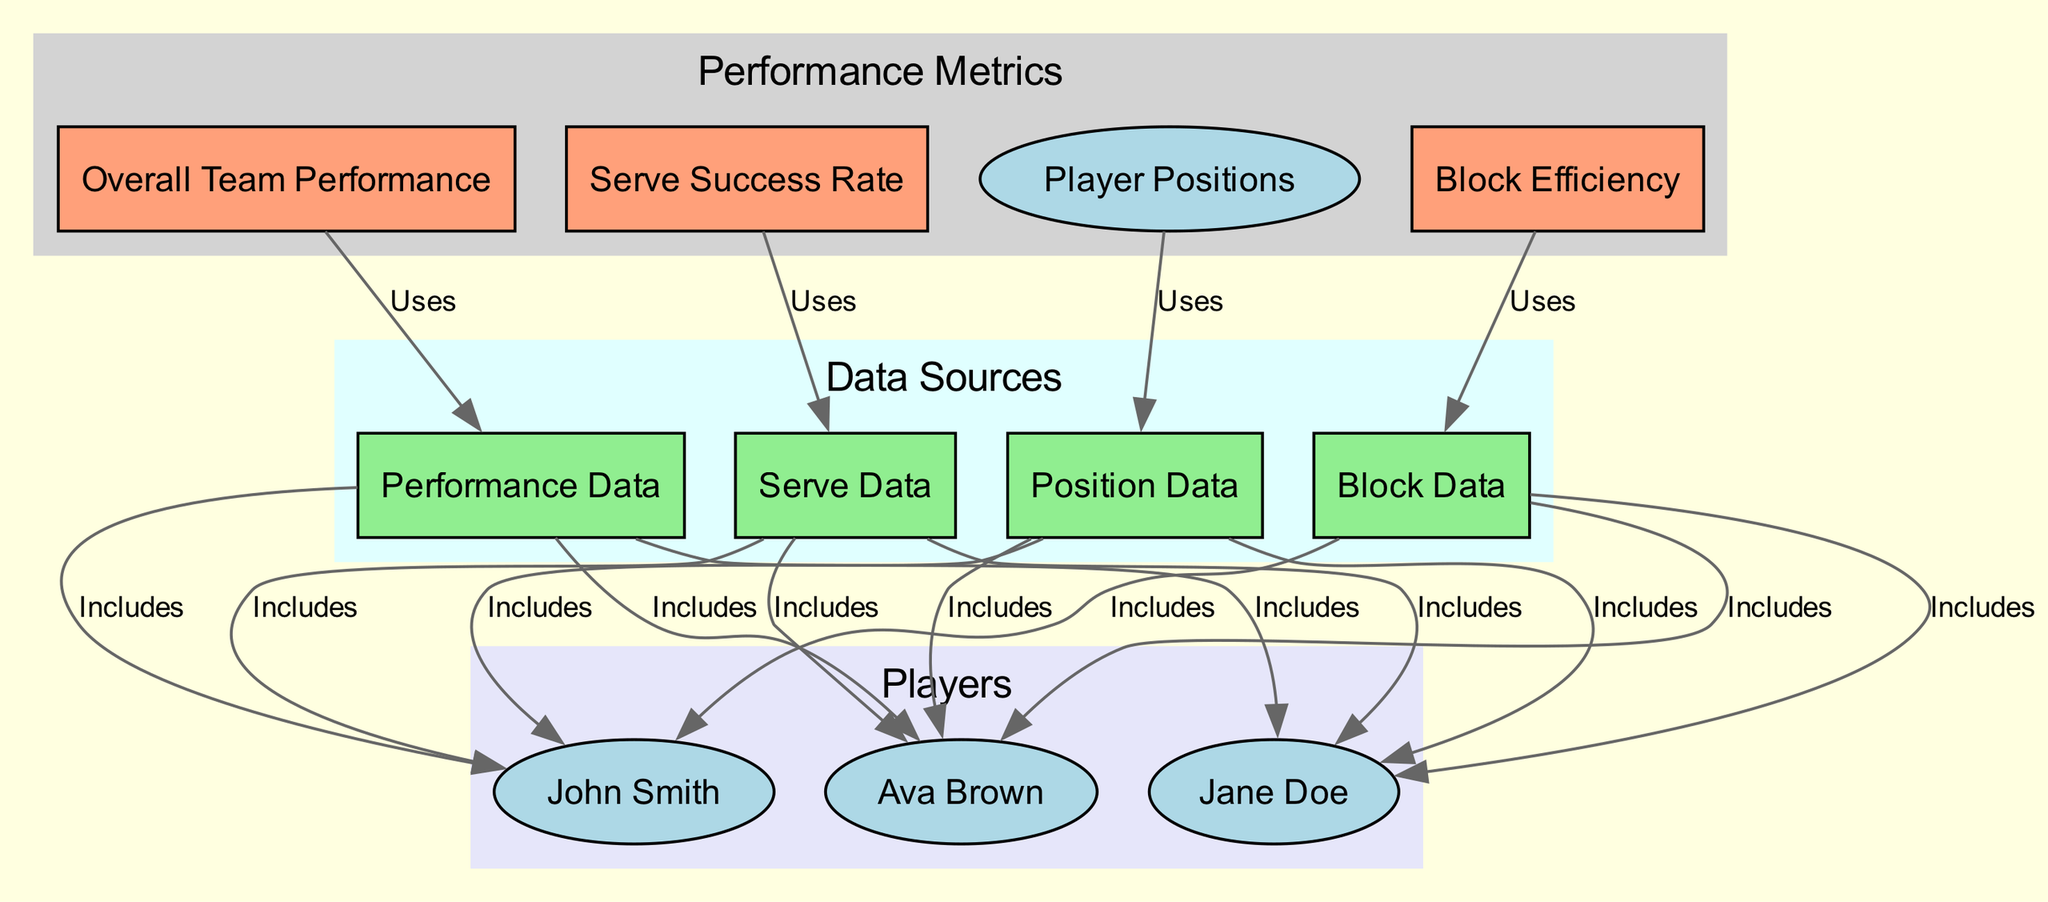What are the four main performance metrics in the diagram? The diagram explicitly labels four nodes under "Performance Metrics": Player Positions, Serve Success Rate, Block Efficiency, and Overall Team Performance. Counting these nodes gives us the four main metrics.
Answer: Player Positions, Serve Success Rate, Block Efficiency, Overall Team Performance How many players are included in the performance dashboard? The diagram has three nodes labeled as players: Jane Doe, John Smith, and Ava Brown. The total number of these nodes gives the count of players included.
Answer: 3 What is the relationship between Serve Success Rate and Serve Data? The diagram shows a directed edge from Serve Success Rate to Serve Data labeled "Uses." This indicates that Serve Success Rate utilizes or is based on the Serve Data.
Answer: Uses Which data source is related to Block Efficiency? There is a directed edge from Block Efficiency to Block Data labeled "Uses." This demonstrates that Block Efficiency relies on Block Data.
Answer: Block Data What colors represent players in the diagram? The nodes for players are filled with light blue color, while the other nodes associated with metrics and data sources are filled with different colors. The color differentiation helps to visually categorize the information presented.
Answer: Light Blue How does Performance Data connect to players? The diagram shows that Performance Data includes edges that connect to each player node, indicating that Performance Data encompasses information from all three players: Jane Doe, John Smith, and Ava Brown.
Answer: Includes all three players Which performance metric is most connected to other nodes? By analyzing the edges, we can see that both Position Data and Serve Data have three connections each, as they include data for all three players. Therefore, they have the most connections to player nodes overall.
Answer: Position Data and Serve Data How many edges are present in the diagram? Counting all the edges presented in the diagram, which connect different nodes together, we find that there are a total of fifteen edges.
Answer: 15 What label connects Team Performance to its data source? The directed edge between Team Performance and Performance Data is labeled "Uses," indicating that Team Performance is dependent on or utilizes Performance Data.
Answer: Uses 